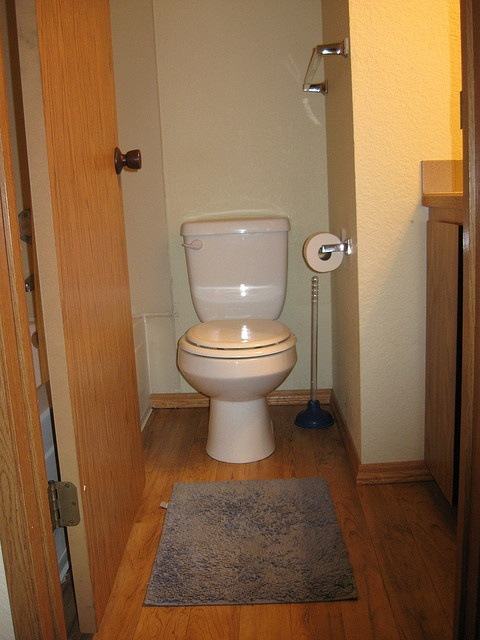Describe the objects in this image and their specific colors. I can see a toilet in maroon, darkgray, gray, and tan tones in this image. 